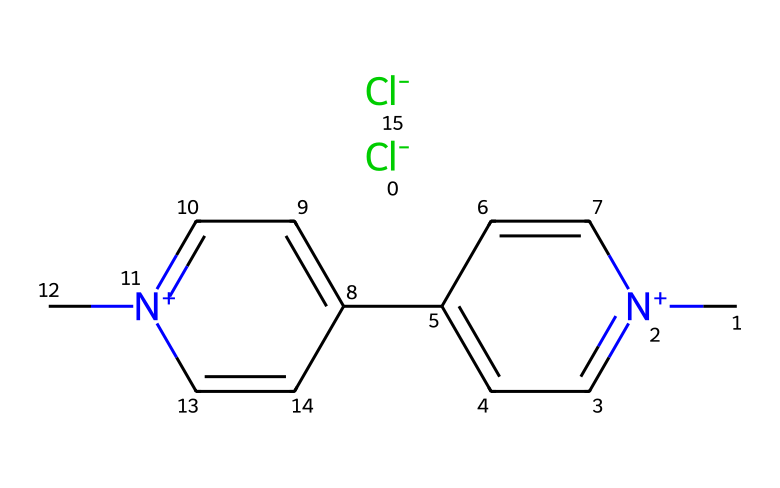What is the molecular formula of paraquat? By examining the SMILES representation, we can identify the number of each type of atom present. There are two chlorine atoms, two nitrogen atoms, ten carbon atoms, and eight hydrogen atoms. Therefore, the molecular formula is C12H14Cl2N2.
Answer: C12H14Cl2N2 How many nitrogen atoms are present in the structure? The SMILES representation shows the presence of two nitrogen atoms (n+), indicated by the 'N' characters in the structure.
Answer: 2 What type of herbicide is paraquat classified as? Paraquat is classified as a non-selective herbicide, which means it can kill a wide range of plants and is not specific to any particular type.
Answer: non-selective What is the charge of the nitrogen atoms in paraquat? In the SMILES representation, the nitrogen atoms are indicated as positively charged (n+), which means each nitrogen has a positive charge.
Answer: positive Why is paraquat considered highly toxic? Paraquat's toxicity is attributed to its chemical structure and mechanism of action, causing oxidative stress and cell damage. This leads to severe health issues in humans and animals upon ingestion.
Answer: oxidative stress How many aromatic rings are present in the paraquat structure? The SMILES representation contains two occurrences of 'c', indicating that there are two aromatic rings in the structure, contributing to its stability and complex interactions.
Answer: 2 What functional group is associated with the toxicity of paraquat? The bipyridinium structure present in paraquat is a functional group associated with its toxicity, as it can disrupt cellular functions by generating reactive oxygen species.
Answer: bipyridinium 